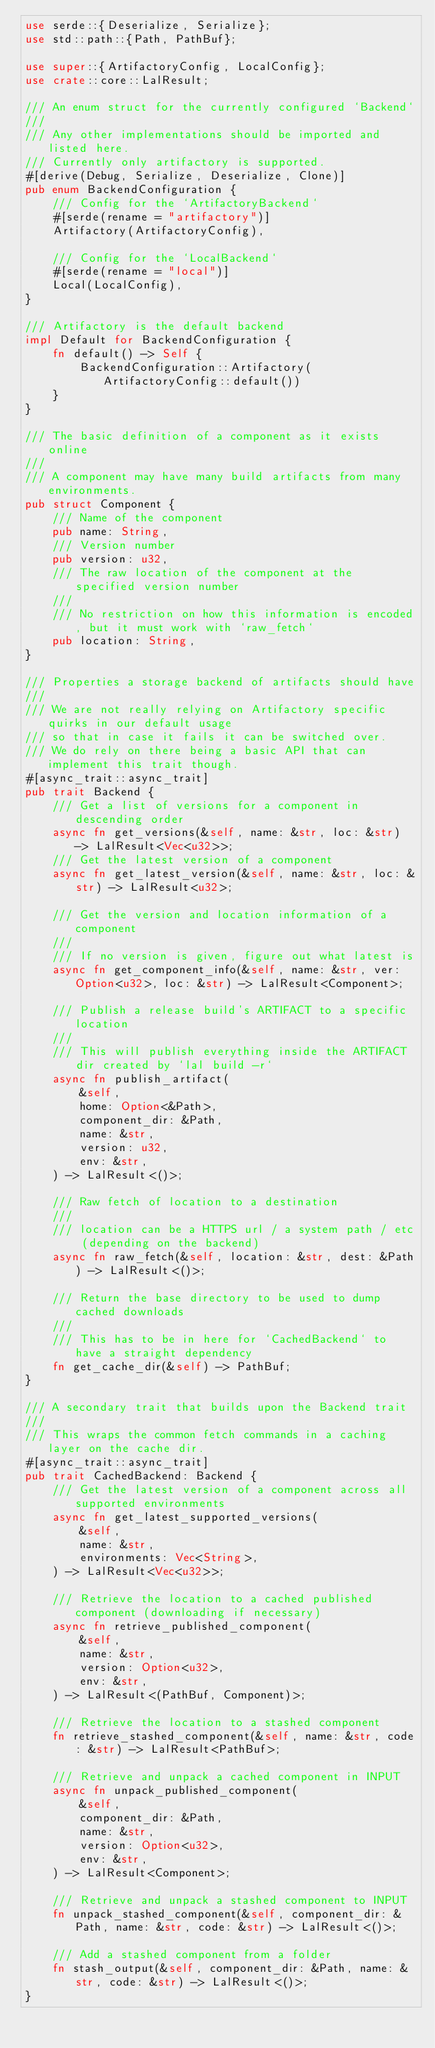<code> <loc_0><loc_0><loc_500><loc_500><_Rust_>use serde::{Deserialize, Serialize};
use std::path::{Path, PathBuf};

use super::{ArtifactoryConfig, LocalConfig};
use crate::core::LalResult;

/// An enum struct for the currently configured `Backend`
///
/// Any other implementations should be imported and listed here.
/// Currently only artifactory is supported.
#[derive(Debug, Serialize, Deserialize, Clone)]
pub enum BackendConfiguration {
    /// Config for the `ArtifactoryBackend`
    #[serde(rename = "artifactory")]
    Artifactory(ArtifactoryConfig),

    /// Config for the `LocalBackend`
    #[serde(rename = "local")]
    Local(LocalConfig),
}

/// Artifactory is the default backend
impl Default for BackendConfiguration {
    fn default() -> Self {
        BackendConfiguration::Artifactory(ArtifactoryConfig::default())
    }
}

/// The basic definition of a component as it exists online
///
/// A component may have many build artifacts from many environments.
pub struct Component {
    /// Name of the component
    pub name: String,
    /// Version number
    pub version: u32,
    /// The raw location of the component at the specified version number
    ///
    /// No restriction on how this information is encoded, but it must work with `raw_fetch`
    pub location: String,
}

/// Properties a storage backend of artifacts should have
///
/// We are not really relying on Artifactory specific quirks in our default usage
/// so that in case it fails it can be switched over.
/// We do rely on there being a basic API that can implement this trait though.
#[async_trait::async_trait]
pub trait Backend {
    /// Get a list of versions for a component in descending order
    async fn get_versions(&self, name: &str, loc: &str) -> LalResult<Vec<u32>>;
    /// Get the latest version of a component
    async fn get_latest_version(&self, name: &str, loc: &str) -> LalResult<u32>;

    /// Get the version and location information of a component
    ///
    /// If no version is given, figure out what latest is
    async fn get_component_info(&self, name: &str, ver: Option<u32>, loc: &str) -> LalResult<Component>;

    /// Publish a release build's ARTIFACT to a specific location
    ///
    /// This will publish everything inside the ARTIFACT dir created by `lal build -r`
    async fn publish_artifact(
        &self,
        home: Option<&Path>,
        component_dir: &Path,
        name: &str,
        version: u32,
        env: &str,
    ) -> LalResult<()>;

    /// Raw fetch of location to a destination
    ///
    /// location can be a HTTPS url / a system path / etc (depending on the backend)
    async fn raw_fetch(&self, location: &str, dest: &Path) -> LalResult<()>;

    /// Return the base directory to be used to dump cached downloads
    ///
    /// This has to be in here for `CachedBackend` to have a straight dependency
    fn get_cache_dir(&self) -> PathBuf;
}

/// A secondary trait that builds upon the Backend trait
///
/// This wraps the common fetch commands in a caching layer on the cache dir.
#[async_trait::async_trait]
pub trait CachedBackend: Backend {
    /// Get the latest version of a component across all supported environments
    async fn get_latest_supported_versions(
        &self,
        name: &str,
        environments: Vec<String>,
    ) -> LalResult<Vec<u32>>;

    /// Retrieve the location to a cached published component (downloading if necessary)
    async fn retrieve_published_component(
        &self,
        name: &str,
        version: Option<u32>,
        env: &str,
    ) -> LalResult<(PathBuf, Component)>;

    /// Retrieve the location to a stashed component
    fn retrieve_stashed_component(&self, name: &str, code: &str) -> LalResult<PathBuf>;

    /// Retrieve and unpack a cached component in INPUT
    async fn unpack_published_component(
        &self,
        component_dir: &Path,
        name: &str,
        version: Option<u32>,
        env: &str,
    ) -> LalResult<Component>;

    /// Retrieve and unpack a stashed component to INPUT
    fn unpack_stashed_component(&self, component_dir: &Path, name: &str, code: &str) -> LalResult<()>;

    /// Add a stashed component from a folder
    fn stash_output(&self, component_dir: &Path, name: &str, code: &str) -> LalResult<()>;
}
</code> 